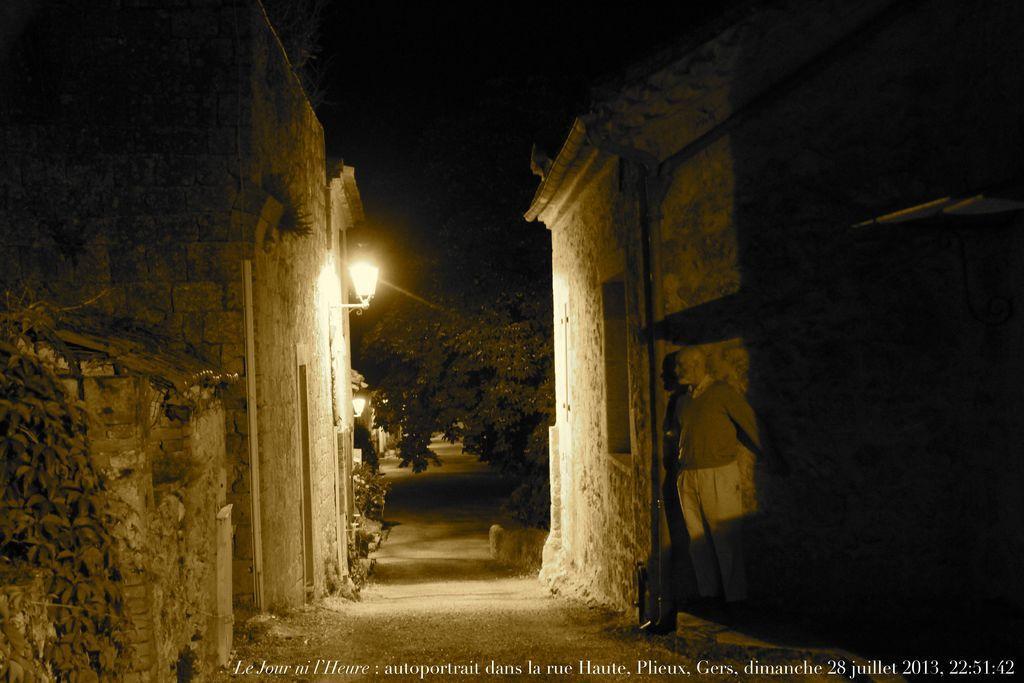How would you summarize this image in a sentence or two? This picture might be taken from outside of the city. In this image, on the right side, we can see a building and a man standing on the land. On the left side, we can also see another building, street lights. In the background, we can see some lights, trees. At the top, we can see black color, at the bottom, we can see a land with some stones. 